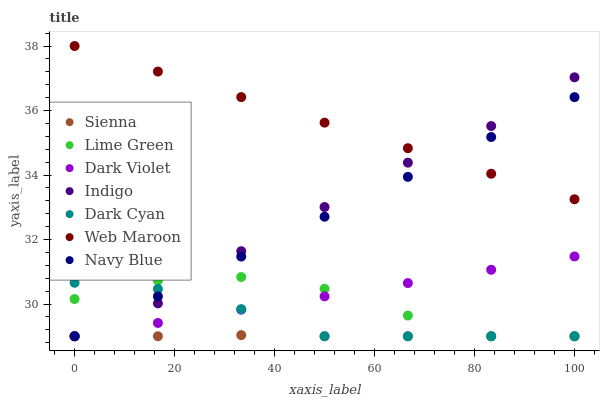Does Sienna have the minimum area under the curve?
Answer yes or no. Yes. Does Web Maroon have the maximum area under the curve?
Answer yes or no. Yes. Does Navy Blue have the minimum area under the curve?
Answer yes or no. No. Does Navy Blue have the maximum area under the curve?
Answer yes or no. No. Is Dark Violet the smoothest?
Answer yes or no. Yes. Is Lime Green the roughest?
Answer yes or no. Yes. Is Navy Blue the smoothest?
Answer yes or no. No. Is Navy Blue the roughest?
Answer yes or no. No. Does Indigo have the lowest value?
Answer yes or no. Yes. Does Web Maroon have the lowest value?
Answer yes or no. No. Does Web Maroon have the highest value?
Answer yes or no. Yes. Does Navy Blue have the highest value?
Answer yes or no. No. Is Dark Violet less than Web Maroon?
Answer yes or no. Yes. Is Web Maroon greater than Dark Violet?
Answer yes or no. Yes. Does Lime Green intersect Dark Violet?
Answer yes or no. Yes. Is Lime Green less than Dark Violet?
Answer yes or no. No. Is Lime Green greater than Dark Violet?
Answer yes or no. No. Does Dark Violet intersect Web Maroon?
Answer yes or no. No. 